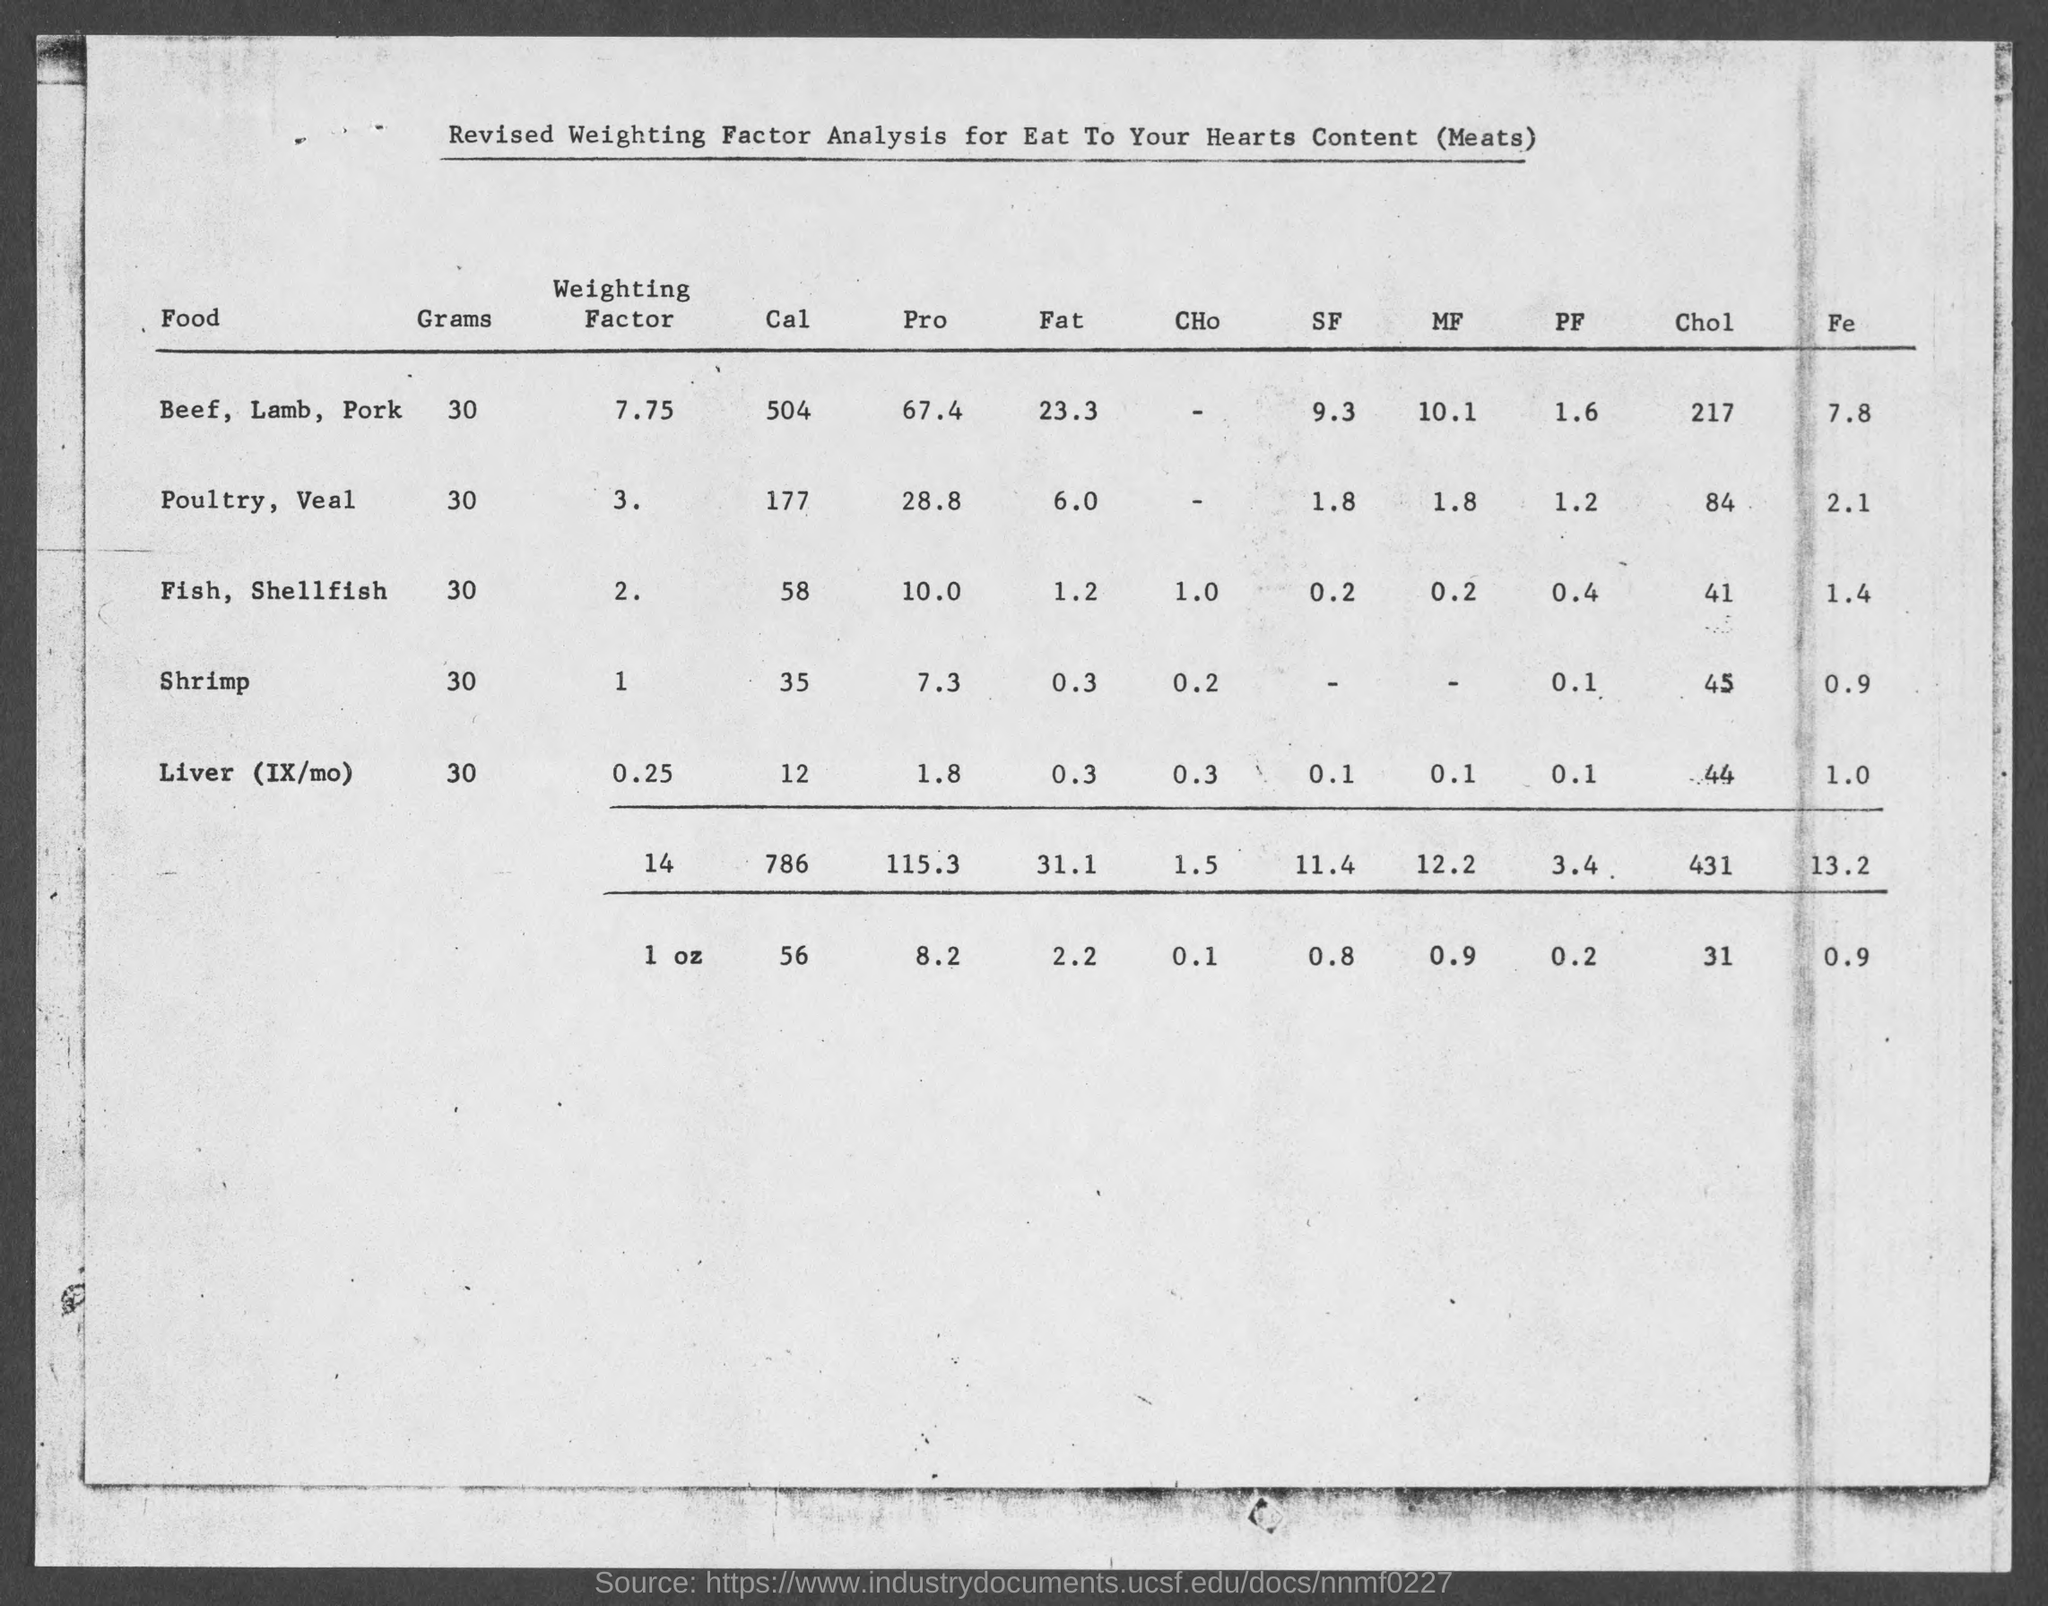Give some essential details in this illustration. 30 grams of Poultry and Veal contains approximately 177 calories. Consuming 30 grams of Fish, Shellfish provides approximately 58 calories. 30 grams of beef, lamb, and pork contain approximately 504 calories. The amount of fat in 30 grams of beef, lamb, and pork is approximately 23.3 grams. 30 grams of Fish, Shellfish contains approximately 1.2 grams of fat. 